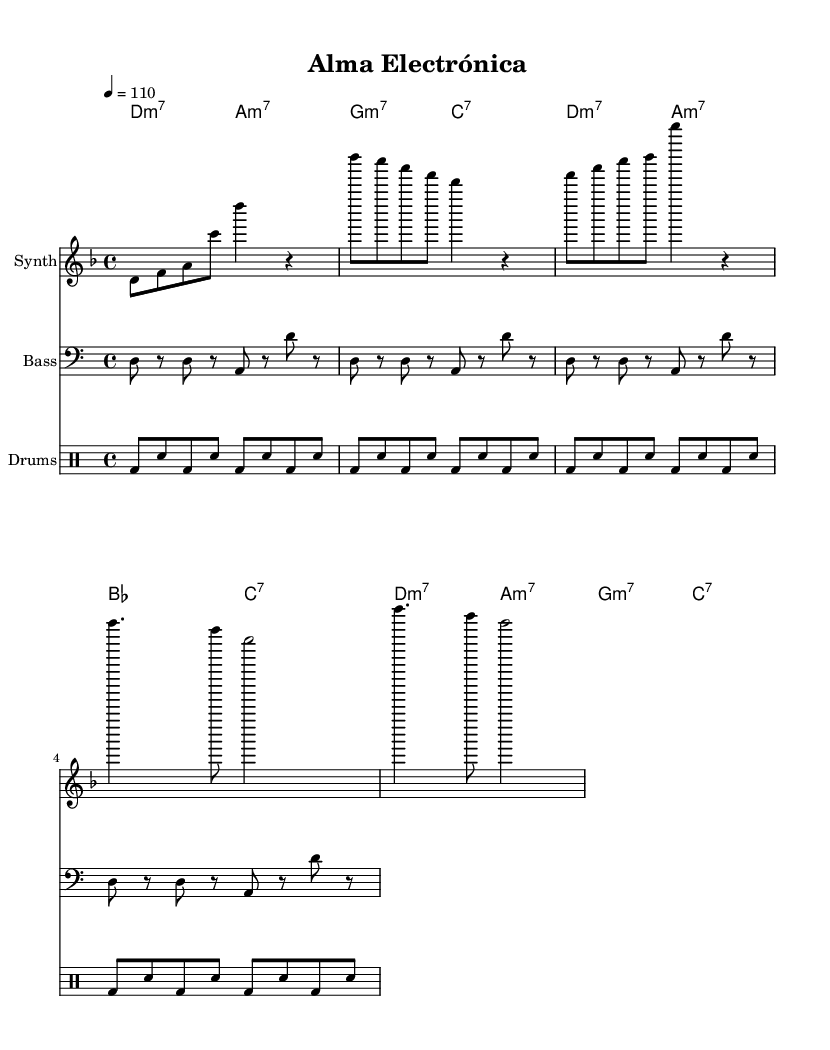What is the key signature of this music? The key signature in the music sheet indicates that the piece is in D minor, as it shows one flat (B flat) typical for D minor scales.
Answer: D minor What is the time signature of this music? The time signature is shown right at the beginning of the music, which is 4/4, meaning there are four beats in each measure.
Answer: 4/4 What is the tempo marking for this piece? The tempo marking in the music sheet indicates a speed of 110 beats per minute, which is specified in the tempo directive.
Answer: 110 What is the chord progression used in the verse? By observing the harmonies indicated under the melody for the verse, the chords are D minor 7, A minor 7, B flat, and C7, which outlines the harmonic movement.
Answer: D minor 7, A minor 7, B flat, C7 What type of rhythmic pattern is used for the drums? The rhythmic section for the drums specifies a repeat of the kick drum and snare drum in eighth notes, contributing to a consistent groove throughout the measures.
Answer: Kick and snare pattern What is the form of the piece based on the sections? The structure or form can be derived from observing the sections: Intro, Verse, and Chorus, giving it a simple AABA format with distinct melodic and harmonic content.
Answer: AABA 